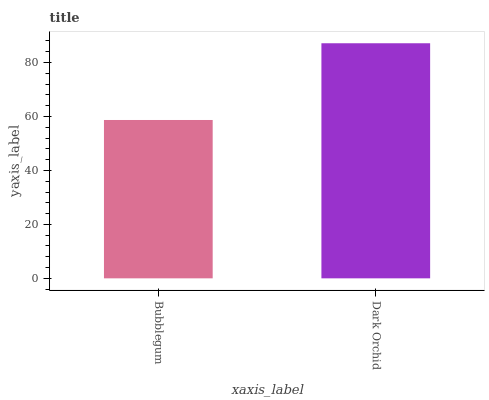Is Bubblegum the minimum?
Answer yes or no. Yes. Is Dark Orchid the maximum?
Answer yes or no. Yes. Is Dark Orchid the minimum?
Answer yes or no. No. Is Dark Orchid greater than Bubblegum?
Answer yes or no. Yes. Is Bubblegum less than Dark Orchid?
Answer yes or no. Yes. Is Bubblegum greater than Dark Orchid?
Answer yes or no. No. Is Dark Orchid less than Bubblegum?
Answer yes or no. No. Is Dark Orchid the high median?
Answer yes or no. Yes. Is Bubblegum the low median?
Answer yes or no. Yes. Is Bubblegum the high median?
Answer yes or no. No. Is Dark Orchid the low median?
Answer yes or no. No. 